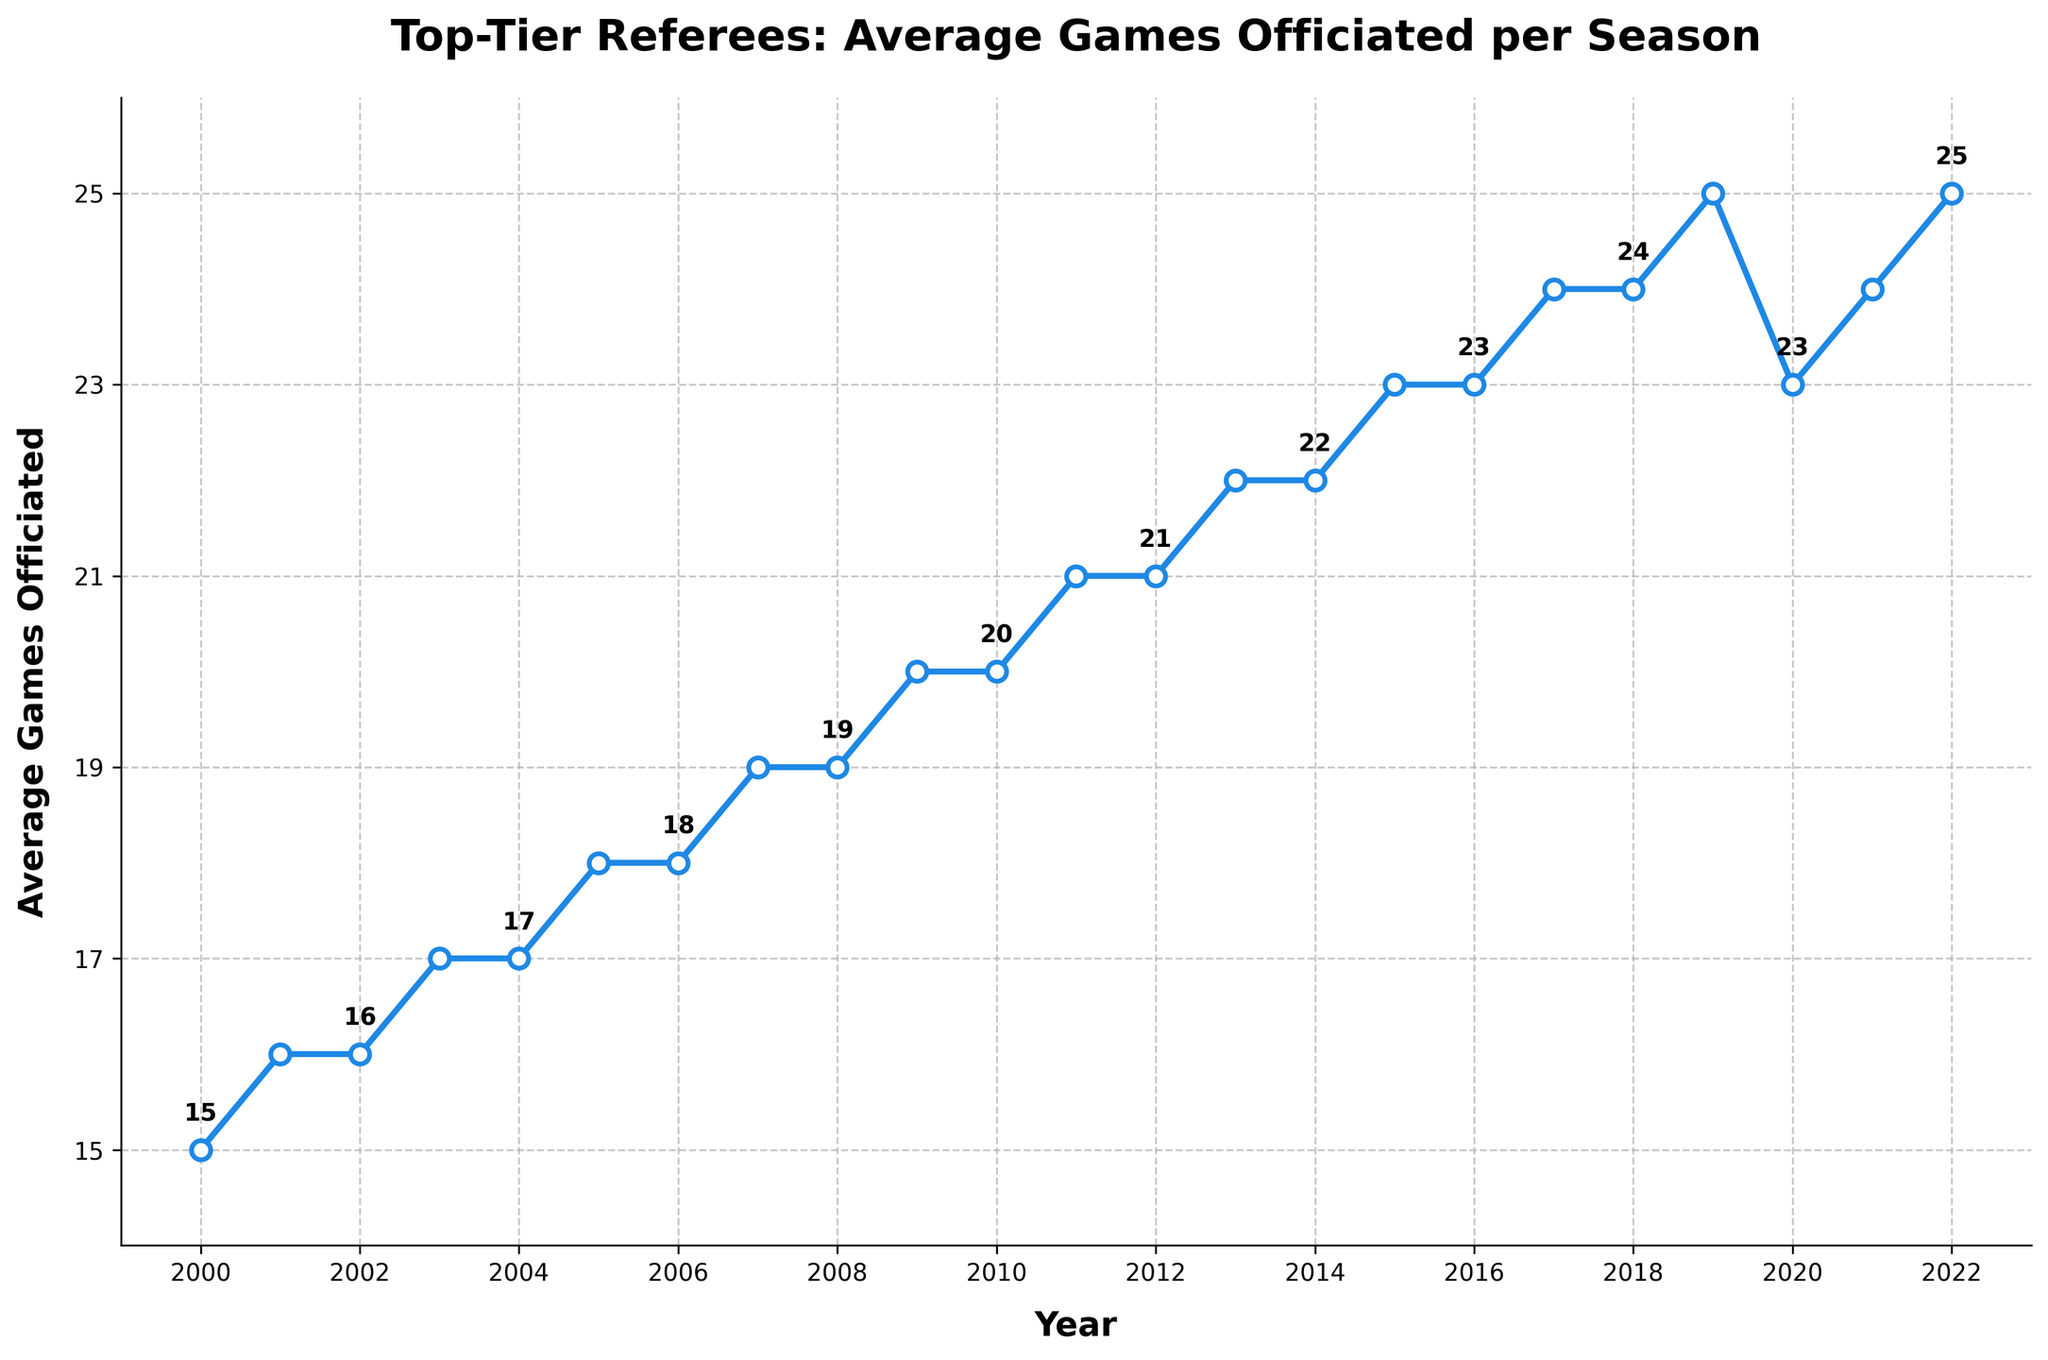What's the average number of games officiated in the first 5 years? Sum the numbers of games officiated from 2000 to 2004 (15 + 16 + 16 + 17 + 17 = 81) and divide by 5.
Answer: 16.2 Between which consecutive years is the largest increase in the average number of games officiated? Check the difference between each pair of consecutive years and find the maximum increase. The largest increase is between 2019 and 2020 (25 - 23 = 2).
Answer: 2019 and 2020 In which year is the number of games officiated equal to 20? Look at the data points to find the year(s) with a value of 20 games officiated. The years are 2009 and 2010.
Answer: 2009 and 2010 How many years have an average of 24 games officiated? Count the number of data points where the average games officiated is 24. These years are 2017, 2018, and 2021.
Answer: 3 What is the trend in the average games officiated from 2000 to 2022? Observe the overall direction of the line plot from 2000 to 2022. The trend shows a general increase in the average number of games officiated, with a slight dip around 2020.
Answer: Increasing Which year experienced the first plateau in the number of games officiated? Inspect the plot for the first instance where the number of games remains the same for two consecutive years. The first plateau occurs between 2001 and 2003 where the value is 16, and then between 2003 and 2004 where the value is 17.
Answer: 2001-2003 and 2003-2004 Calculate the average number of games officiated over the entire period. Sum the numbers of games officiated from 2000 to 2022 (451) and divide by the number of years (23).
Answer: 19.6 How many times did the average number of games officiated decline from one year to the next? Check each pair of consecutive years to see how many times the average number of games declined. The declines occur from 2019 to 2020 (25 to 23), and from 2020 to 2021 (23 to 24, it actually increases, no decline at 2021).
Answer: 1 What is the largest single-year drop in the average number of games officiated? Calculate the difference between each pair of consecutive years where the next year's number is smaller and find the largest drop. The largest single-year drop occurs between 2019 and 2020 (25 - 23 = 2).
Answer: 2 